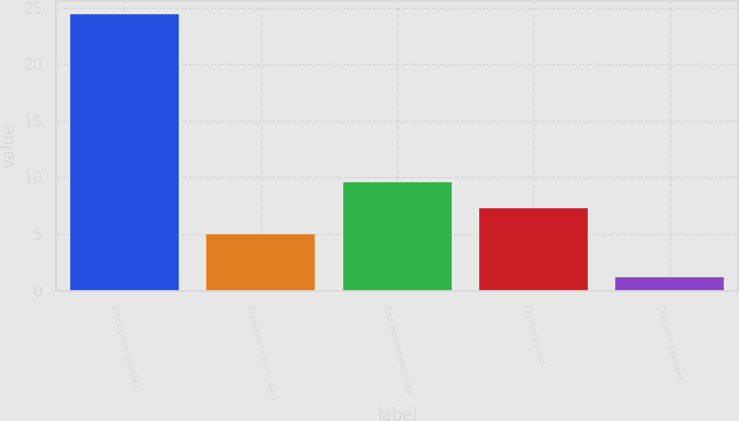Convert chart to OTSL. <chart><loc_0><loc_0><loc_500><loc_500><bar_chart><fcel>Stock price volatility<fcel>Expected term in years<fcel>Risk-free interest rate<fcel>Dividend yield<fcel>Dividend payment<nl><fcel>24.4<fcel>5<fcel>9.64<fcel>7.32<fcel>1.2<nl></chart> 